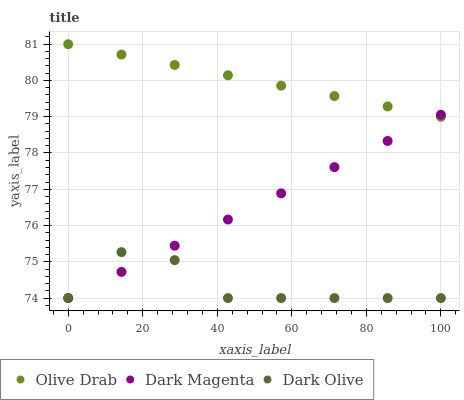Does Dark Olive have the minimum area under the curve?
Answer yes or no. Yes. Does Olive Drab have the maximum area under the curve?
Answer yes or no. Yes. Does Dark Magenta have the minimum area under the curve?
Answer yes or no. No. Does Dark Magenta have the maximum area under the curve?
Answer yes or no. No. Is Dark Magenta the smoothest?
Answer yes or no. Yes. Is Dark Olive the roughest?
Answer yes or no. Yes. Is Olive Drab the smoothest?
Answer yes or no. No. Is Olive Drab the roughest?
Answer yes or no. No. Does Dark Olive have the lowest value?
Answer yes or no. Yes. Does Olive Drab have the lowest value?
Answer yes or no. No. Does Olive Drab have the highest value?
Answer yes or no. Yes. Does Dark Magenta have the highest value?
Answer yes or no. No. Is Dark Olive less than Olive Drab?
Answer yes or no. Yes. Is Olive Drab greater than Dark Olive?
Answer yes or no. Yes. Does Dark Magenta intersect Dark Olive?
Answer yes or no. Yes. Is Dark Magenta less than Dark Olive?
Answer yes or no. No. Is Dark Magenta greater than Dark Olive?
Answer yes or no. No. Does Dark Olive intersect Olive Drab?
Answer yes or no. No. 